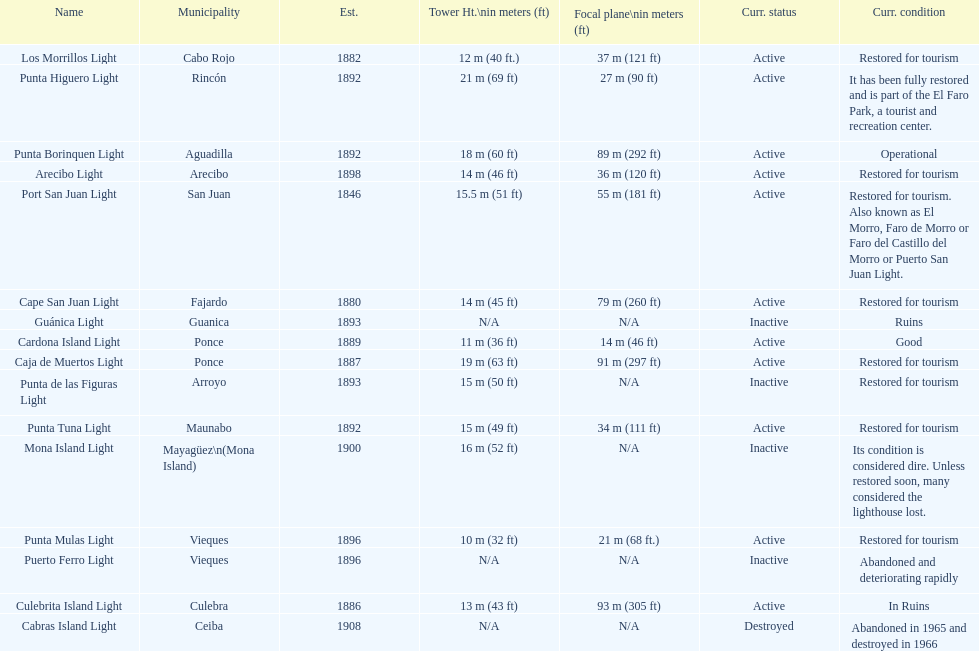What is the largest tower Punta Higuero Light. 